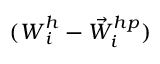Convert formula to latex. <formula><loc_0><loc_0><loc_500><loc_500>( W _ { i } ^ { h } - { \vec { W } } _ { i } ^ { h p } )</formula> 